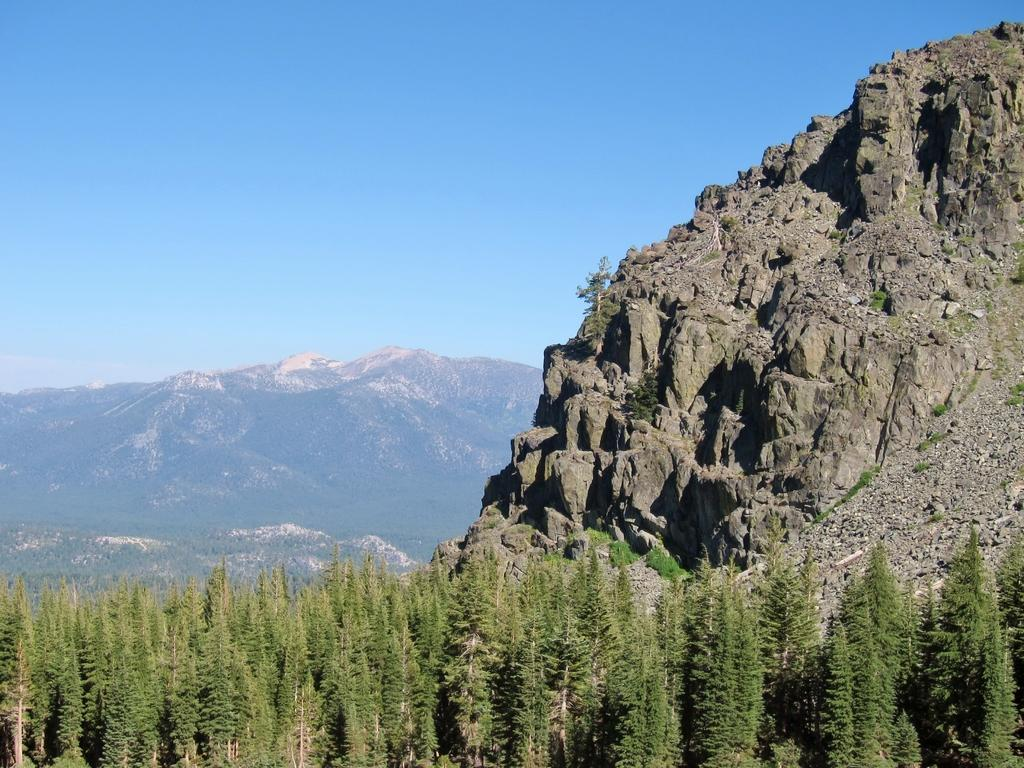What type of natural landform can be seen in the image? There are mountains in the image. What type of vegetation is present in the image? There are trees in the image. What is visible at the top of the image? The sky is visible at the top of the image. Where is the crate located in the image? There is no crate present in the image. Can you see any geese in the image? There are no geese present in the image. 